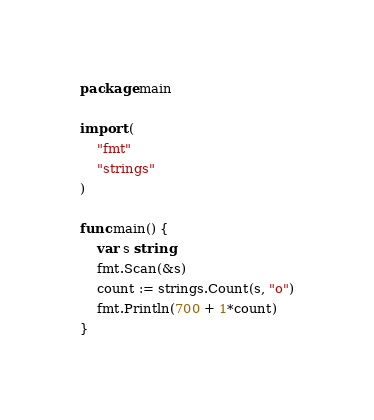Convert code to text. <code><loc_0><loc_0><loc_500><loc_500><_Go_>package main

import (
	"fmt"
	"strings"
)

func main() {
	var s string
	fmt.Scan(&s)
	count := strings.Count(s, "o")
	fmt.Println(700 + 1*count)
}
</code> 